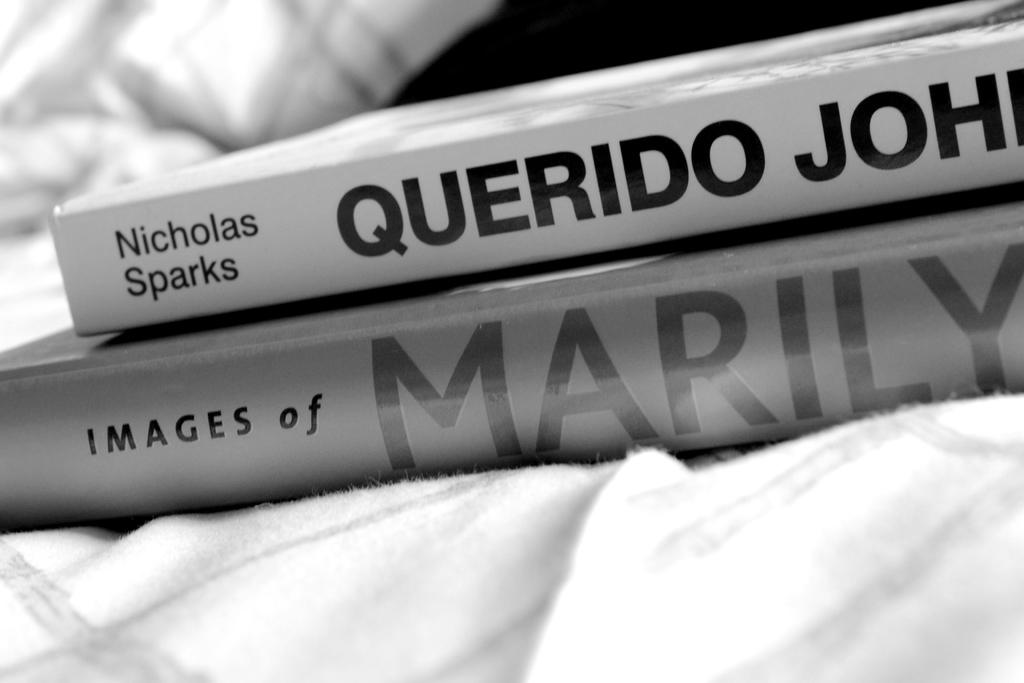What objects can be seen in the image? There are books in the image. What color is the cloth in the image? The cloth in the image is white. Can you describe the background of the image? The background of the image is blurred. How does the hope in the image feel about the temper of the cats? There is no mention of hope or cats in the image, so it is not possible to answer that question. 